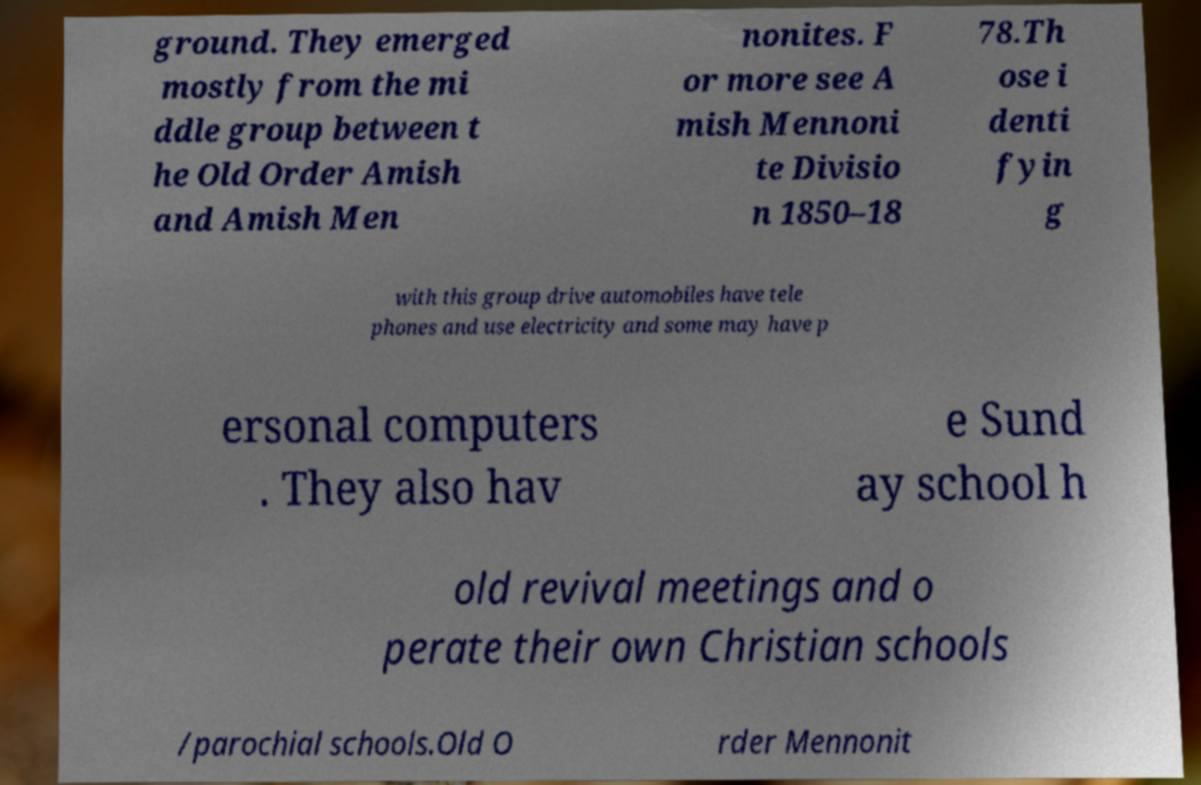I need the written content from this picture converted into text. Can you do that? ground. They emerged mostly from the mi ddle group between t he Old Order Amish and Amish Men nonites. F or more see A mish Mennoni te Divisio n 1850–18 78.Th ose i denti fyin g with this group drive automobiles have tele phones and use electricity and some may have p ersonal computers . They also hav e Sund ay school h old revival meetings and o perate their own Christian schools /parochial schools.Old O rder Mennonit 